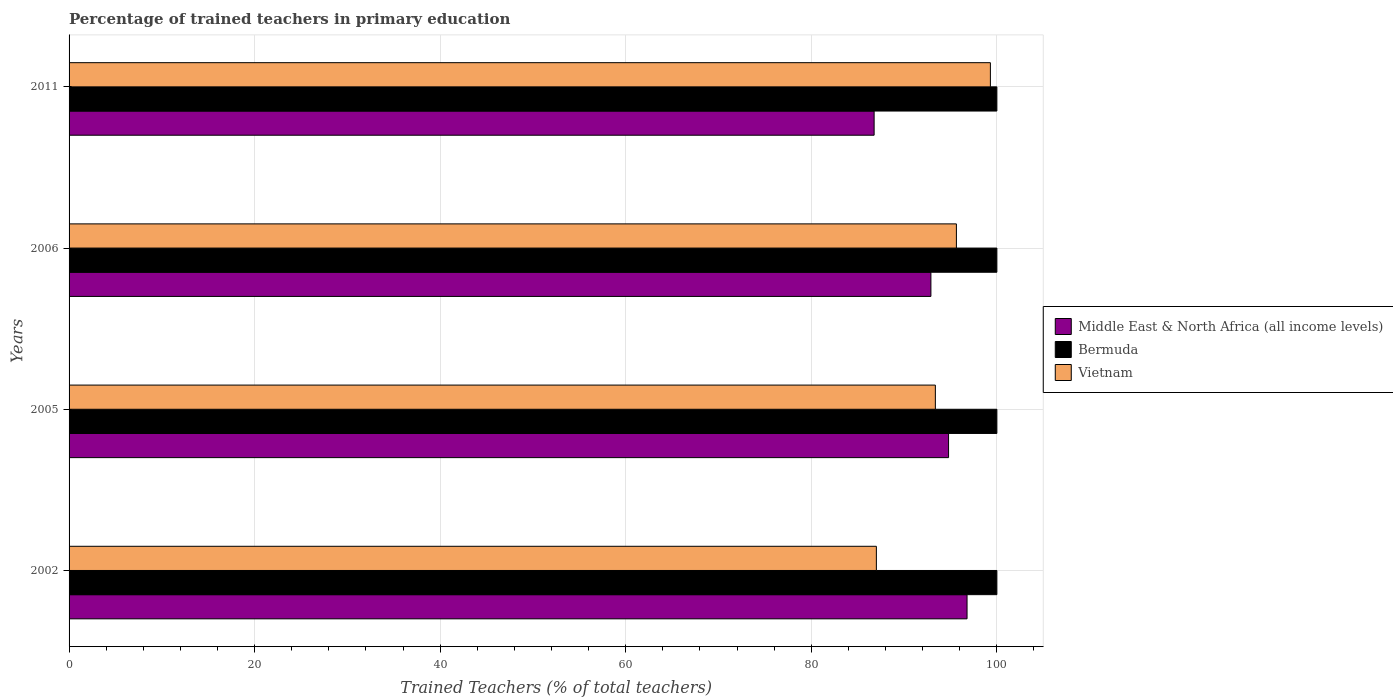How many different coloured bars are there?
Your response must be concise. 3. How many groups of bars are there?
Offer a very short reply. 4. Are the number of bars on each tick of the Y-axis equal?
Offer a terse response. Yes. In how many cases, is the number of bars for a given year not equal to the number of legend labels?
Keep it short and to the point. 0. Across all years, what is the maximum percentage of trained teachers in Middle East & North Africa (all income levels)?
Offer a very short reply. 96.79. Across all years, what is the minimum percentage of trained teachers in Vietnam?
Give a very brief answer. 87.01. In which year was the percentage of trained teachers in Middle East & North Africa (all income levels) minimum?
Give a very brief answer. 2011. What is the total percentage of trained teachers in Middle East & North Africa (all income levels) in the graph?
Offer a very short reply. 371.24. What is the difference between the percentage of trained teachers in Bermuda in 2002 and that in 2005?
Offer a terse response. 0. What is the difference between the percentage of trained teachers in Middle East & North Africa (all income levels) in 2005 and the percentage of trained teachers in Bermuda in 2002?
Your answer should be compact. -5.21. What is the average percentage of trained teachers in Vietnam per year?
Offer a very short reply. 93.83. In the year 2006, what is the difference between the percentage of trained teachers in Middle East & North Africa (all income levels) and percentage of trained teachers in Bermuda?
Offer a very short reply. -7.11. What is the ratio of the percentage of trained teachers in Middle East & North Africa (all income levels) in 2006 to that in 2011?
Give a very brief answer. 1.07. Is the difference between the percentage of trained teachers in Middle East & North Africa (all income levels) in 2005 and 2011 greater than the difference between the percentage of trained teachers in Bermuda in 2005 and 2011?
Provide a short and direct response. Yes. What is the difference between the highest and the second highest percentage of trained teachers in Bermuda?
Make the answer very short. 0. What is the difference between the highest and the lowest percentage of trained teachers in Vietnam?
Make the answer very short. 12.29. What does the 3rd bar from the top in 2002 represents?
Provide a short and direct response. Middle East & North Africa (all income levels). What does the 1st bar from the bottom in 2002 represents?
Give a very brief answer. Middle East & North Africa (all income levels). How many bars are there?
Your answer should be compact. 12. Does the graph contain grids?
Offer a very short reply. Yes. Where does the legend appear in the graph?
Ensure brevity in your answer.  Center right. How are the legend labels stacked?
Keep it short and to the point. Vertical. What is the title of the graph?
Make the answer very short. Percentage of trained teachers in primary education. What is the label or title of the X-axis?
Your response must be concise. Trained Teachers (% of total teachers). What is the label or title of the Y-axis?
Offer a terse response. Years. What is the Trained Teachers (% of total teachers) of Middle East & North Africa (all income levels) in 2002?
Your answer should be compact. 96.79. What is the Trained Teachers (% of total teachers) in Bermuda in 2002?
Keep it short and to the point. 100. What is the Trained Teachers (% of total teachers) of Vietnam in 2002?
Offer a very short reply. 87.01. What is the Trained Teachers (% of total teachers) in Middle East & North Africa (all income levels) in 2005?
Offer a terse response. 94.79. What is the Trained Teachers (% of total teachers) of Vietnam in 2005?
Give a very brief answer. 93.37. What is the Trained Teachers (% of total teachers) in Middle East & North Africa (all income levels) in 2006?
Give a very brief answer. 92.89. What is the Trained Teachers (% of total teachers) of Bermuda in 2006?
Keep it short and to the point. 100. What is the Trained Teachers (% of total teachers) of Vietnam in 2006?
Make the answer very short. 95.64. What is the Trained Teachers (% of total teachers) of Middle East & North Africa (all income levels) in 2011?
Keep it short and to the point. 86.77. What is the Trained Teachers (% of total teachers) in Bermuda in 2011?
Offer a terse response. 100. What is the Trained Teachers (% of total teachers) of Vietnam in 2011?
Your answer should be very brief. 99.3. Across all years, what is the maximum Trained Teachers (% of total teachers) of Middle East & North Africa (all income levels)?
Your answer should be compact. 96.79. Across all years, what is the maximum Trained Teachers (% of total teachers) of Bermuda?
Provide a short and direct response. 100. Across all years, what is the maximum Trained Teachers (% of total teachers) in Vietnam?
Offer a very short reply. 99.3. Across all years, what is the minimum Trained Teachers (% of total teachers) in Middle East & North Africa (all income levels)?
Ensure brevity in your answer.  86.77. Across all years, what is the minimum Trained Teachers (% of total teachers) in Bermuda?
Your response must be concise. 100. Across all years, what is the minimum Trained Teachers (% of total teachers) in Vietnam?
Provide a succinct answer. 87.01. What is the total Trained Teachers (% of total teachers) of Middle East & North Africa (all income levels) in the graph?
Ensure brevity in your answer.  371.24. What is the total Trained Teachers (% of total teachers) in Vietnam in the graph?
Your response must be concise. 375.32. What is the difference between the Trained Teachers (% of total teachers) of Middle East & North Africa (all income levels) in 2002 and that in 2005?
Your answer should be very brief. 1.99. What is the difference between the Trained Teachers (% of total teachers) of Vietnam in 2002 and that in 2005?
Provide a short and direct response. -6.36. What is the difference between the Trained Teachers (% of total teachers) of Middle East & North Africa (all income levels) in 2002 and that in 2006?
Your response must be concise. 3.9. What is the difference between the Trained Teachers (% of total teachers) in Bermuda in 2002 and that in 2006?
Offer a very short reply. 0. What is the difference between the Trained Teachers (% of total teachers) in Vietnam in 2002 and that in 2006?
Keep it short and to the point. -8.63. What is the difference between the Trained Teachers (% of total teachers) in Middle East & North Africa (all income levels) in 2002 and that in 2011?
Keep it short and to the point. 10.02. What is the difference between the Trained Teachers (% of total teachers) in Bermuda in 2002 and that in 2011?
Keep it short and to the point. 0. What is the difference between the Trained Teachers (% of total teachers) of Vietnam in 2002 and that in 2011?
Keep it short and to the point. -12.29. What is the difference between the Trained Teachers (% of total teachers) of Middle East & North Africa (all income levels) in 2005 and that in 2006?
Keep it short and to the point. 1.9. What is the difference between the Trained Teachers (% of total teachers) of Vietnam in 2005 and that in 2006?
Offer a terse response. -2.27. What is the difference between the Trained Teachers (% of total teachers) in Middle East & North Africa (all income levels) in 2005 and that in 2011?
Offer a very short reply. 8.02. What is the difference between the Trained Teachers (% of total teachers) of Bermuda in 2005 and that in 2011?
Your answer should be compact. 0. What is the difference between the Trained Teachers (% of total teachers) in Vietnam in 2005 and that in 2011?
Provide a short and direct response. -5.93. What is the difference between the Trained Teachers (% of total teachers) of Middle East & North Africa (all income levels) in 2006 and that in 2011?
Your answer should be very brief. 6.12. What is the difference between the Trained Teachers (% of total teachers) of Bermuda in 2006 and that in 2011?
Your response must be concise. 0. What is the difference between the Trained Teachers (% of total teachers) of Vietnam in 2006 and that in 2011?
Provide a succinct answer. -3.66. What is the difference between the Trained Teachers (% of total teachers) in Middle East & North Africa (all income levels) in 2002 and the Trained Teachers (% of total teachers) in Bermuda in 2005?
Offer a very short reply. -3.21. What is the difference between the Trained Teachers (% of total teachers) in Middle East & North Africa (all income levels) in 2002 and the Trained Teachers (% of total teachers) in Vietnam in 2005?
Provide a short and direct response. 3.42. What is the difference between the Trained Teachers (% of total teachers) of Bermuda in 2002 and the Trained Teachers (% of total teachers) of Vietnam in 2005?
Ensure brevity in your answer.  6.63. What is the difference between the Trained Teachers (% of total teachers) of Middle East & North Africa (all income levels) in 2002 and the Trained Teachers (% of total teachers) of Bermuda in 2006?
Offer a very short reply. -3.21. What is the difference between the Trained Teachers (% of total teachers) in Middle East & North Africa (all income levels) in 2002 and the Trained Teachers (% of total teachers) in Vietnam in 2006?
Your response must be concise. 1.15. What is the difference between the Trained Teachers (% of total teachers) in Bermuda in 2002 and the Trained Teachers (% of total teachers) in Vietnam in 2006?
Provide a short and direct response. 4.36. What is the difference between the Trained Teachers (% of total teachers) in Middle East & North Africa (all income levels) in 2002 and the Trained Teachers (% of total teachers) in Bermuda in 2011?
Ensure brevity in your answer.  -3.21. What is the difference between the Trained Teachers (% of total teachers) of Middle East & North Africa (all income levels) in 2002 and the Trained Teachers (% of total teachers) of Vietnam in 2011?
Your answer should be very brief. -2.52. What is the difference between the Trained Teachers (% of total teachers) in Bermuda in 2002 and the Trained Teachers (% of total teachers) in Vietnam in 2011?
Make the answer very short. 0.7. What is the difference between the Trained Teachers (% of total teachers) of Middle East & North Africa (all income levels) in 2005 and the Trained Teachers (% of total teachers) of Bermuda in 2006?
Give a very brief answer. -5.21. What is the difference between the Trained Teachers (% of total teachers) in Middle East & North Africa (all income levels) in 2005 and the Trained Teachers (% of total teachers) in Vietnam in 2006?
Your response must be concise. -0.85. What is the difference between the Trained Teachers (% of total teachers) of Bermuda in 2005 and the Trained Teachers (% of total teachers) of Vietnam in 2006?
Provide a succinct answer. 4.36. What is the difference between the Trained Teachers (% of total teachers) in Middle East & North Africa (all income levels) in 2005 and the Trained Teachers (% of total teachers) in Bermuda in 2011?
Ensure brevity in your answer.  -5.21. What is the difference between the Trained Teachers (% of total teachers) of Middle East & North Africa (all income levels) in 2005 and the Trained Teachers (% of total teachers) of Vietnam in 2011?
Your answer should be compact. -4.51. What is the difference between the Trained Teachers (% of total teachers) of Bermuda in 2005 and the Trained Teachers (% of total teachers) of Vietnam in 2011?
Give a very brief answer. 0.7. What is the difference between the Trained Teachers (% of total teachers) in Middle East & North Africa (all income levels) in 2006 and the Trained Teachers (% of total teachers) in Bermuda in 2011?
Ensure brevity in your answer.  -7.11. What is the difference between the Trained Teachers (% of total teachers) in Middle East & North Africa (all income levels) in 2006 and the Trained Teachers (% of total teachers) in Vietnam in 2011?
Provide a succinct answer. -6.41. What is the difference between the Trained Teachers (% of total teachers) in Bermuda in 2006 and the Trained Teachers (% of total teachers) in Vietnam in 2011?
Keep it short and to the point. 0.7. What is the average Trained Teachers (% of total teachers) in Middle East & North Africa (all income levels) per year?
Give a very brief answer. 92.81. What is the average Trained Teachers (% of total teachers) in Bermuda per year?
Your answer should be compact. 100. What is the average Trained Teachers (% of total teachers) in Vietnam per year?
Your response must be concise. 93.83. In the year 2002, what is the difference between the Trained Teachers (% of total teachers) in Middle East & North Africa (all income levels) and Trained Teachers (% of total teachers) in Bermuda?
Give a very brief answer. -3.21. In the year 2002, what is the difference between the Trained Teachers (% of total teachers) of Middle East & North Africa (all income levels) and Trained Teachers (% of total teachers) of Vietnam?
Offer a very short reply. 9.77. In the year 2002, what is the difference between the Trained Teachers (% of total teachers) of Bermuda and Trained Teachers (% of total teachers) of Vietnam?
Provide a short and direct response. 12.99. In the year 2005, what is the difference between the Trained Teachers (% of total teachers) in Middle East & North Africa (all income levels) and Trained Teachers (% of total teachers) in Bermuda?
Give a very brief answer. -5.21. In the year 2005, what is the difference between the Trained Teachers (% of total teachers) in Middle East & North Africa (all income levels) and Trained Teachers (% of total teachers) in Vietnam?
Offer a terse response. 1.42. In the year 2005, what is the difference between the Trained Teachers (% of total teachers) in Bermuda and Trained Teachers (% of total teachers) in Vietnam?
Provide a succinct answer. 6.63. In the year 2006, what is the difference between the Trained Teachers (% of total teachers) of Middle East & North Africa (all income levels) and Trained Teachers (% of total teachers) of Bermuda?
Ensure brevity in your answer.  -7.11. In the year 2006, what is the difference between the Trained Teachers (% of total teachers) in Middle East & North Africa (all income levels) and Trained Teachers (% of total teachers) in Vietnam?
Your response must be concise. -2.75. In the year 2006, what is the difference between the Trained Teachers (% of total teachers) in Bermuda and Trained Teachers (% of total teachers) in Vietnam?
Provide a short and direct response. 4.36. In the year 2011, what is the difference between the Trained Teachers (% of total teachers) of Middle East & North Africa (all income levels) and Trained Teachers (% of total teachers) of Bermuda?
Your answer should be very brief. -13.23. In the year 2011, what is the difference between the Trained Teachers (% of total teachers) in Middle East & North Africa (all income levels) and Trained Teachers (% of total teachers) in Vietnam?
Give a very brief answer. -12.53. In the year 2011, what is the difference between the Trained Teachers (% of total teachers) of Bermuda and Trained Teachers (% of total teachers) of Vietnam?
Offer a terse response. 0.7. What is the ratio of the Trained Teachers (% of total teachers) in Middle East & North Africa (all income levels) in 2002 to that in 2005?
Your response must be concise. 1.02. What is the ratio of the Trained Teachers (% of total teachers) in Vietnam in 2002 to that in 2005?
Provide a short and direct response. 0.93. What is the ratio of the Trained Teachers (% of total teachers) in Middle East & North Africa (all income levels) in 2002 to that in 2006?
Provide a succinct answer. 1.04. What is the ratio of the Trained Teachers (% of total teachers) of Vietnam in 2002 to that in 2006?
Offer a terse response. 0.91. What is the ratio of the Trained Teachers (% of total teachers) in Middle East & North Africa (all income levels) in 2002 to that in 2011?
Give a very brief answer. 1.12. What is the ratio of the Trained Teachers (% of total teachers) in Vietnam in 2002 to that in 2011?
Ensure brevity in your answer.  0.88. What is the ratio of the Trained Teachers (% of total teachers) in Middle East & North Africa (all income levels) in 2005 to that in 2006?
Provide a short and direct response. 1.02. What is the ratio of the Trained Teachers (% of total teachers) of Vietnam in 2005 to that in 2006?
Keep it short and to the point. 0.98. What is the ratio of the Trained Teachers (% of total teachers) of Middle East & North Africa (all income levels) in 2005 to that in 2011?
Provide a short and direct response. 1.09. What is the ratio of the Trained Teachers (% of total teachers) in Bermuda in 2005 to that in 2011?
Your response must be concise. 1. What is the ratio of the Trained Teachers (% of total teachers) of Vietnam in 2005 to that in 2011?
Make the answer very short. 0.94. What is the ratio of the Trained Teachers (% of total teachers) in Middle East & North Africa (all income levels) in 2006 to that in 2011?
Offer a very short reply. 1.07. What is the ratio of the Trained Teachers (% of total teachers) of Vietnam in 2006 to that in 2011?
Your answer should be compact. 0.96. What is the difference between the highest and the second highest Trained Teachers (% of total teachers) of Middle East & North Africa (all income levels)?
Offer a terse response. 1.99. What is the difference between the highest and the second highest Trained Teachers (% of total teachers) of Bermuda?
Offer a terse response. 0. What is the difference between the highest and the second highest Trained Teachers (% of total teachers) of Vietnam?
Your answer should be very brief. 3.66. What is the difference between the highest and the lowest Trained Teachers (% of total teachers) in Middle East & North Africa (all income levels)?
Ensure brevity in your answer.  10.02. What is the difference between the highest and the lowest Trained Teachers (% of total teachers) of Vietnam?
Give a very brief answer. 12.29. 